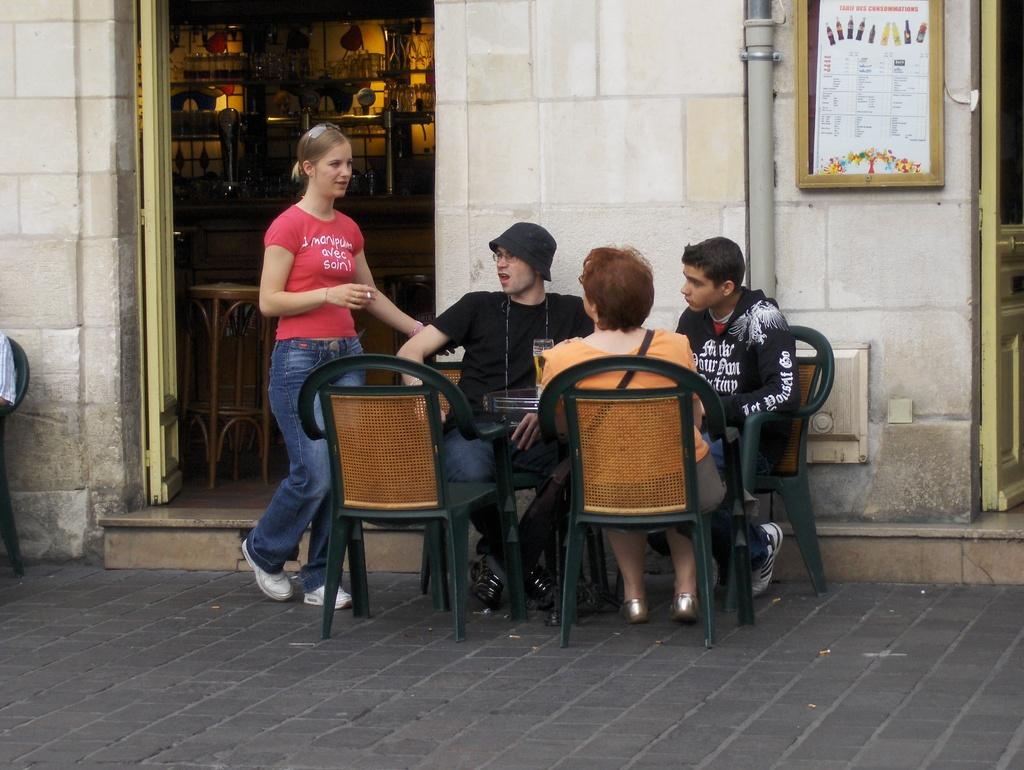How many people are sitting on chairs in the middle of the image? There are three people sitting on chairs in the middle of the image. What is the gender of the person on the left side of the image? There is a woman on the left side of the image. What can be seen in the background of the image? There is a building, a wall, a photo frame, and a door in the background of the image. What type of lettuce is being used as a tablecloth in the image? There is no lettuce present in the image, and it is not being used as a tablecloth. Can you describe the creature that is sitting on the chairs with the people? There is no creature present in the image; only the three people are sitting on the chairs. 